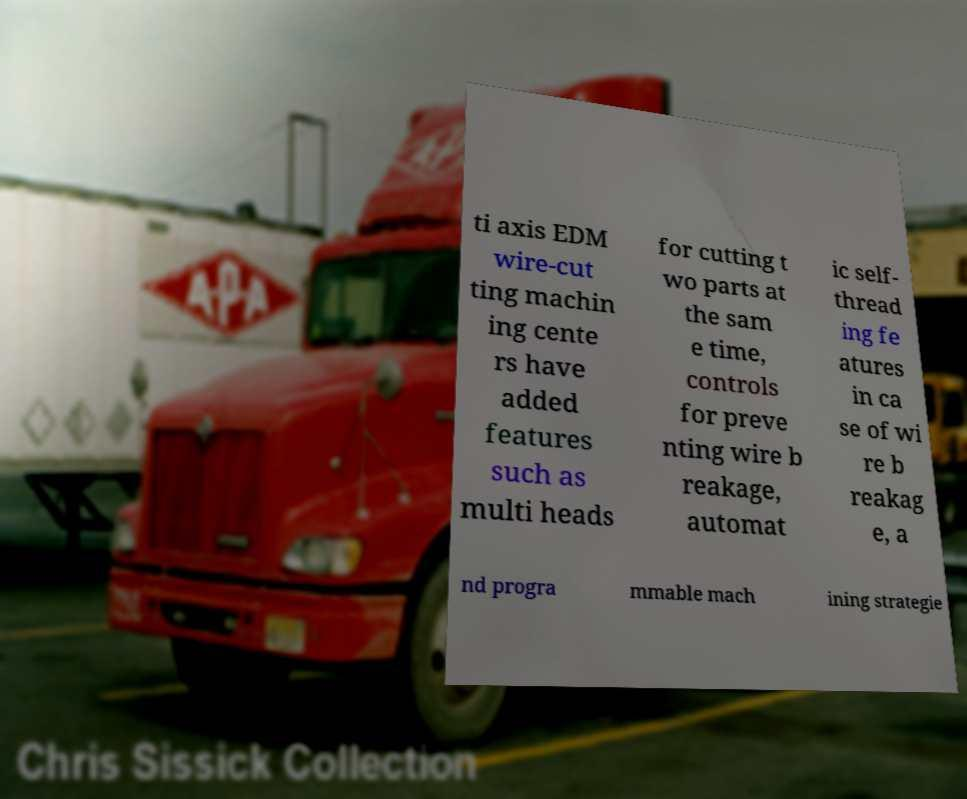Can you accurately transcribe the text from the provided image for me? ti axis EDM wire-cut ting machin ing cente rs have added features such as multi heads for cutting t wo parts at the sam e time, controls for preve nting wire b reakage, automat ic self- thread ing fe atures in ca se of wi re b reakag e, a nd progra mmable mach ining strategie 